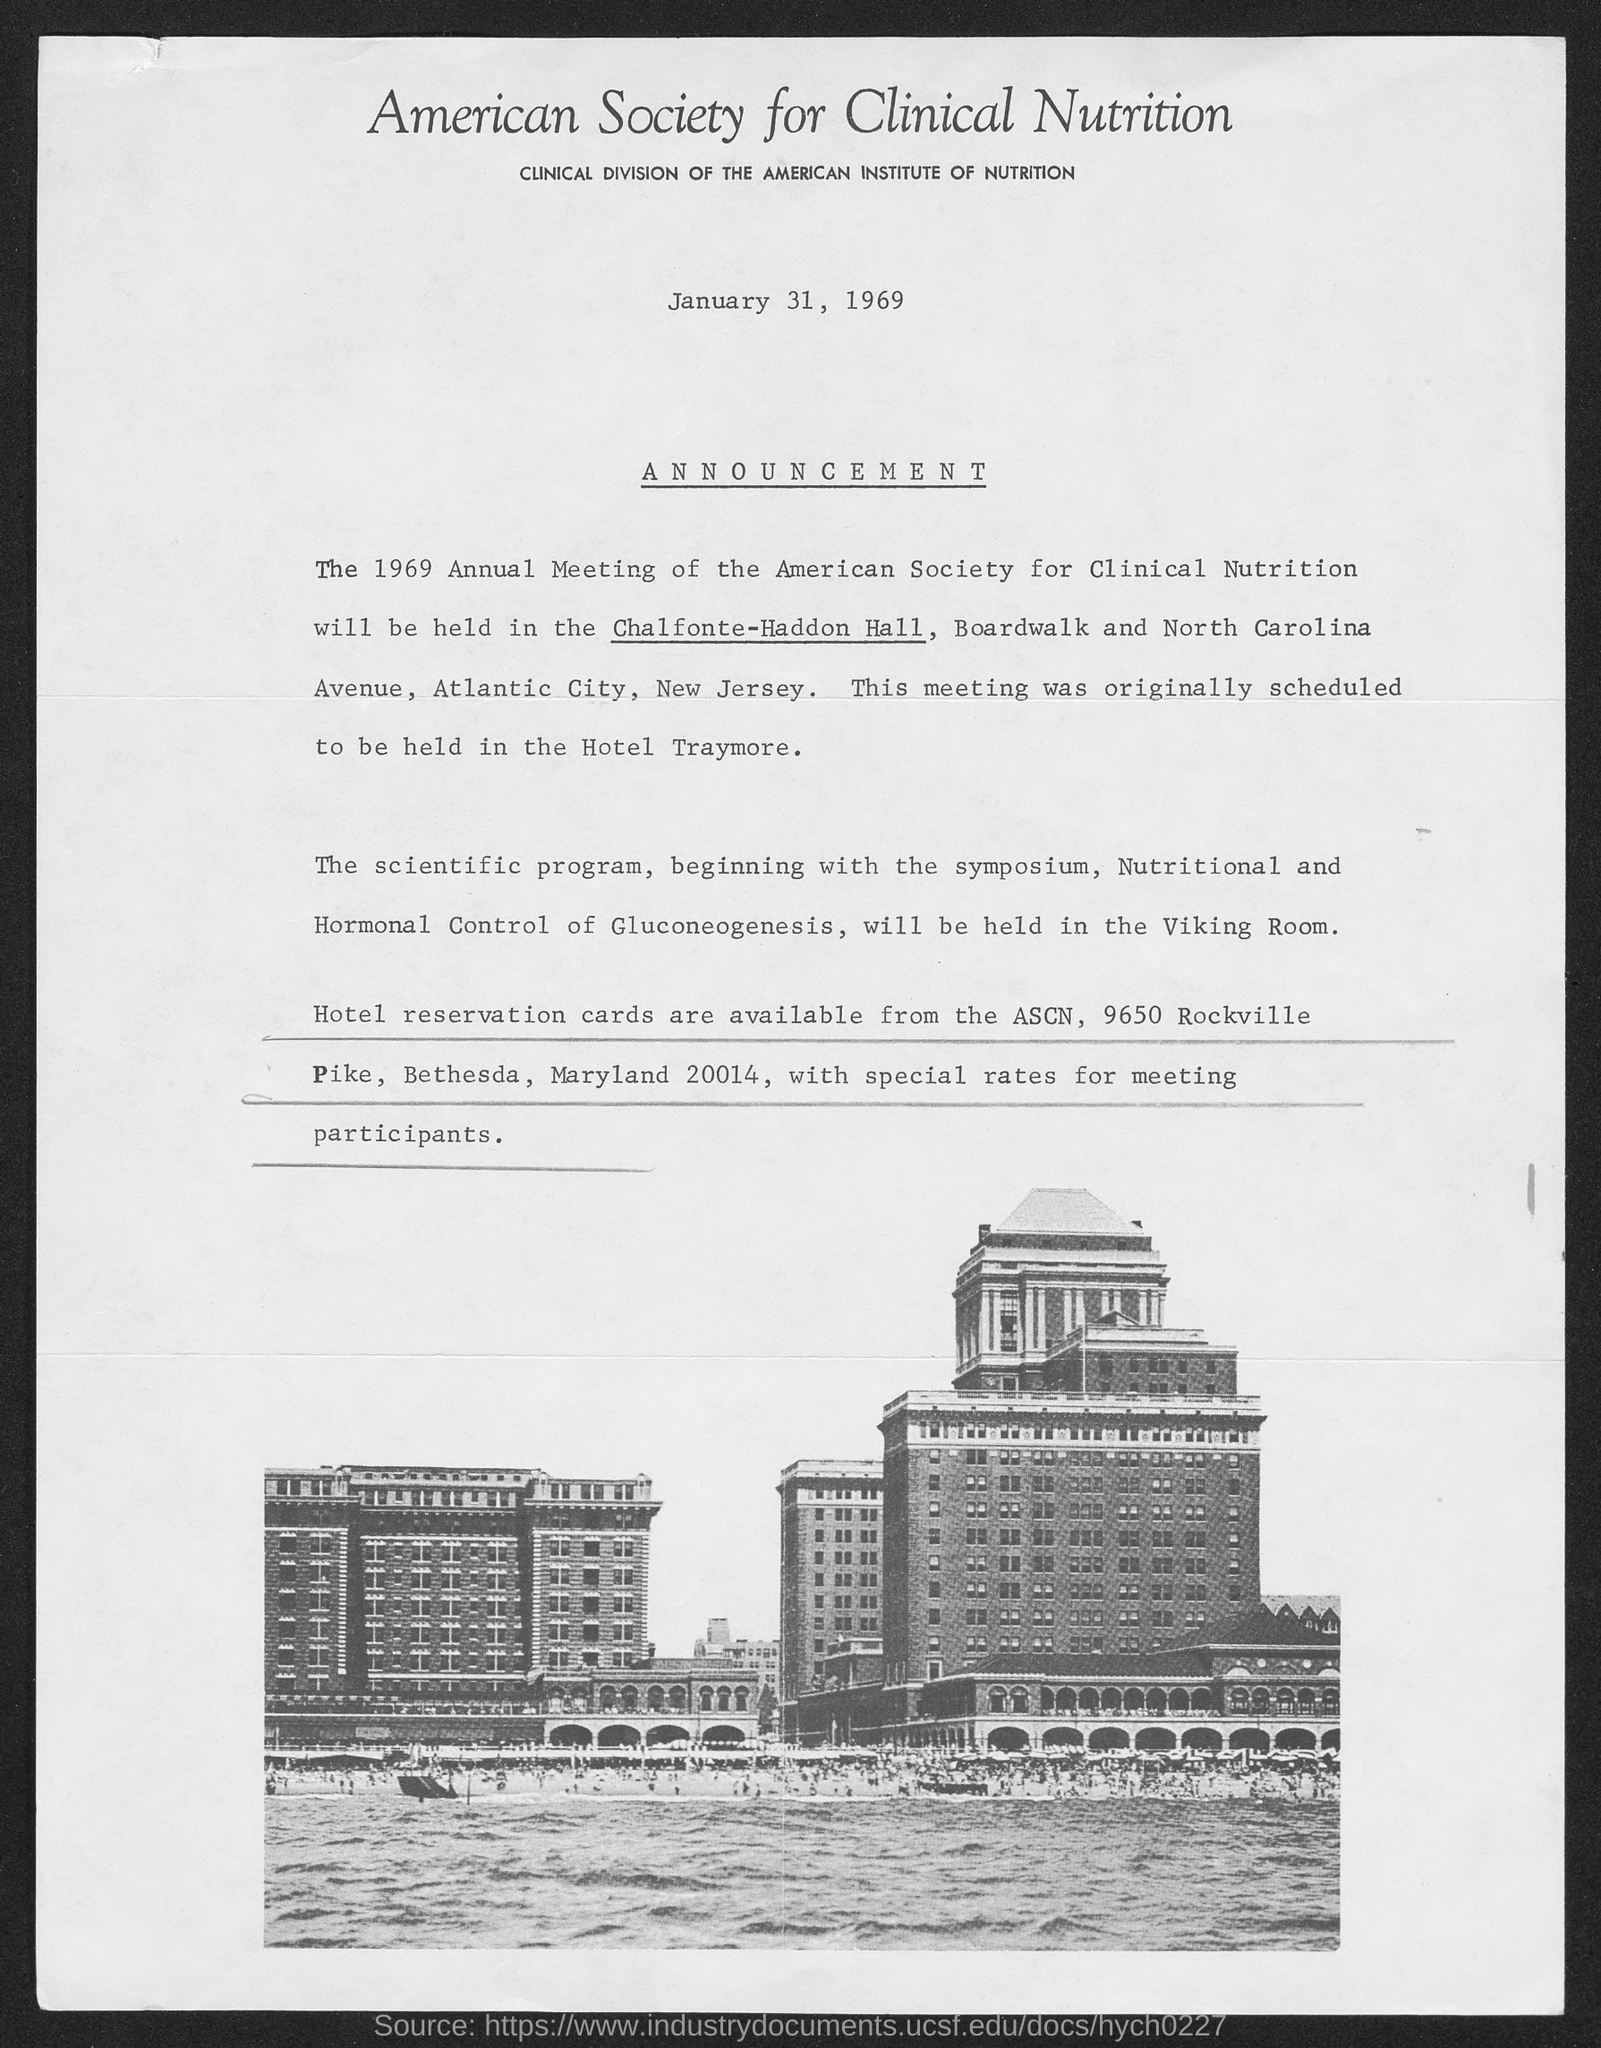Draw attention to some important aspects in this diagram. The scientific program will be held in the Viking Room. The document is dated January 31, 1969. The meeting was originally scheduled to be held at the Hotel Traymore. The 1969 Annual Meeting will be held at Chalfonte-Haddon Hall. The American Society for Clinical Nutrition is the clinical division of the American Institute of Nutrition. 